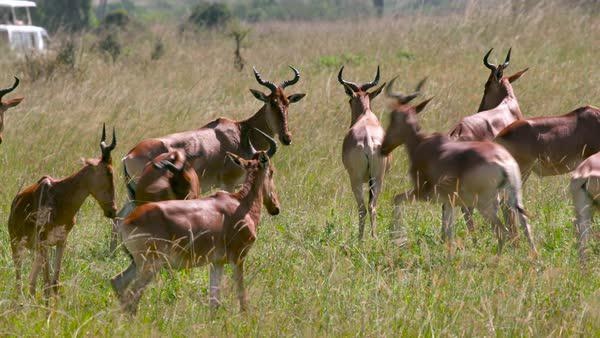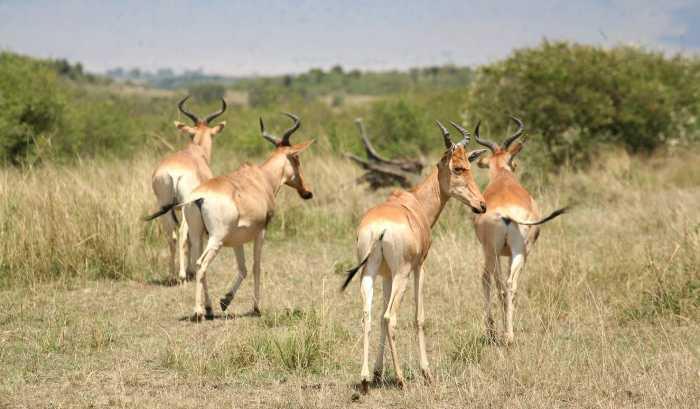The first image is the image on the left, the second image is the image on the right. Considering the images on both sides, is "One of the images contains no more than four antelopes" valid? Answer yes or no. Yes. The first image is the image on the left, the second image is the image on the right. Assess this claim about the two images: "All the horned animals in one image have their rears turned to the camera.". Correct or not? Answer yes or no. Yes. The first image is the image on the left, the second image is the image on the right. Considering the images on both sides, is "There are 5 antelopes in the right most image." valid? Answer yes or no. No. The first image is the image on the left, the second image is the image on the right. For the images shown, is this caption "An image shows a group of five antelope type animals." true? Answer yes or no. No. 